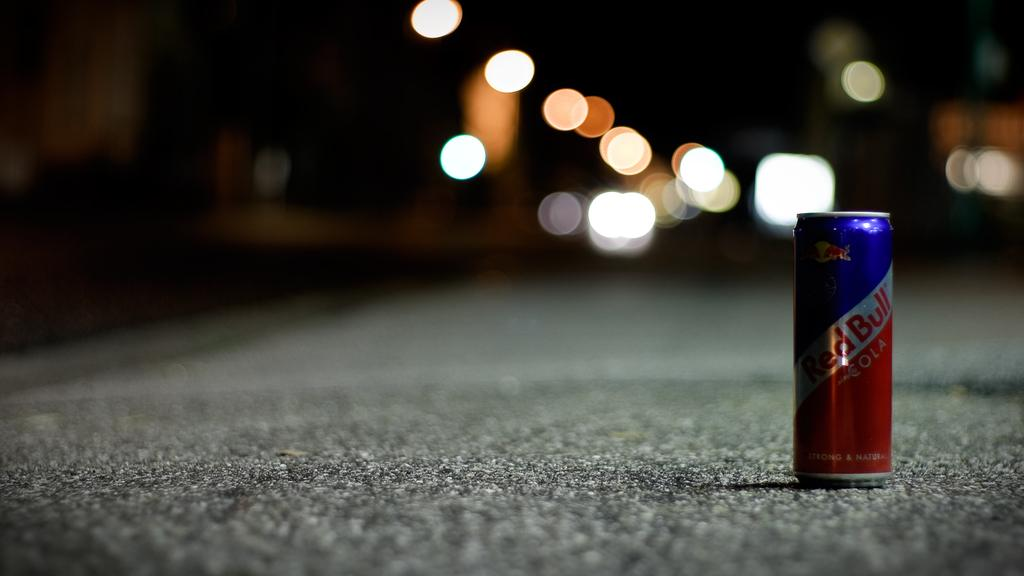<image>
Share a concise interpretation of the image provided. a Red Bull drink that is on the street 